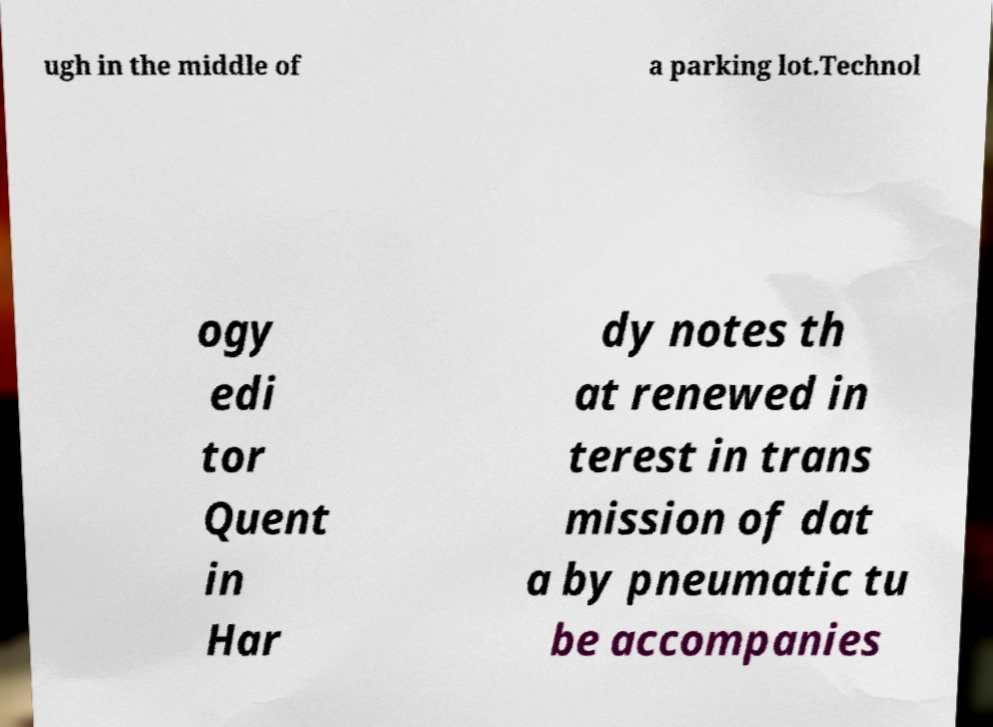For documentation purposes, I need the text within this image transcribed. Could you provide that? ugh in the middle of a parking lot.Technol ogy edi tor Quent in Har dy notes th at renewed in terest in trans mission of dat a by pneumatic tu be accompanies 